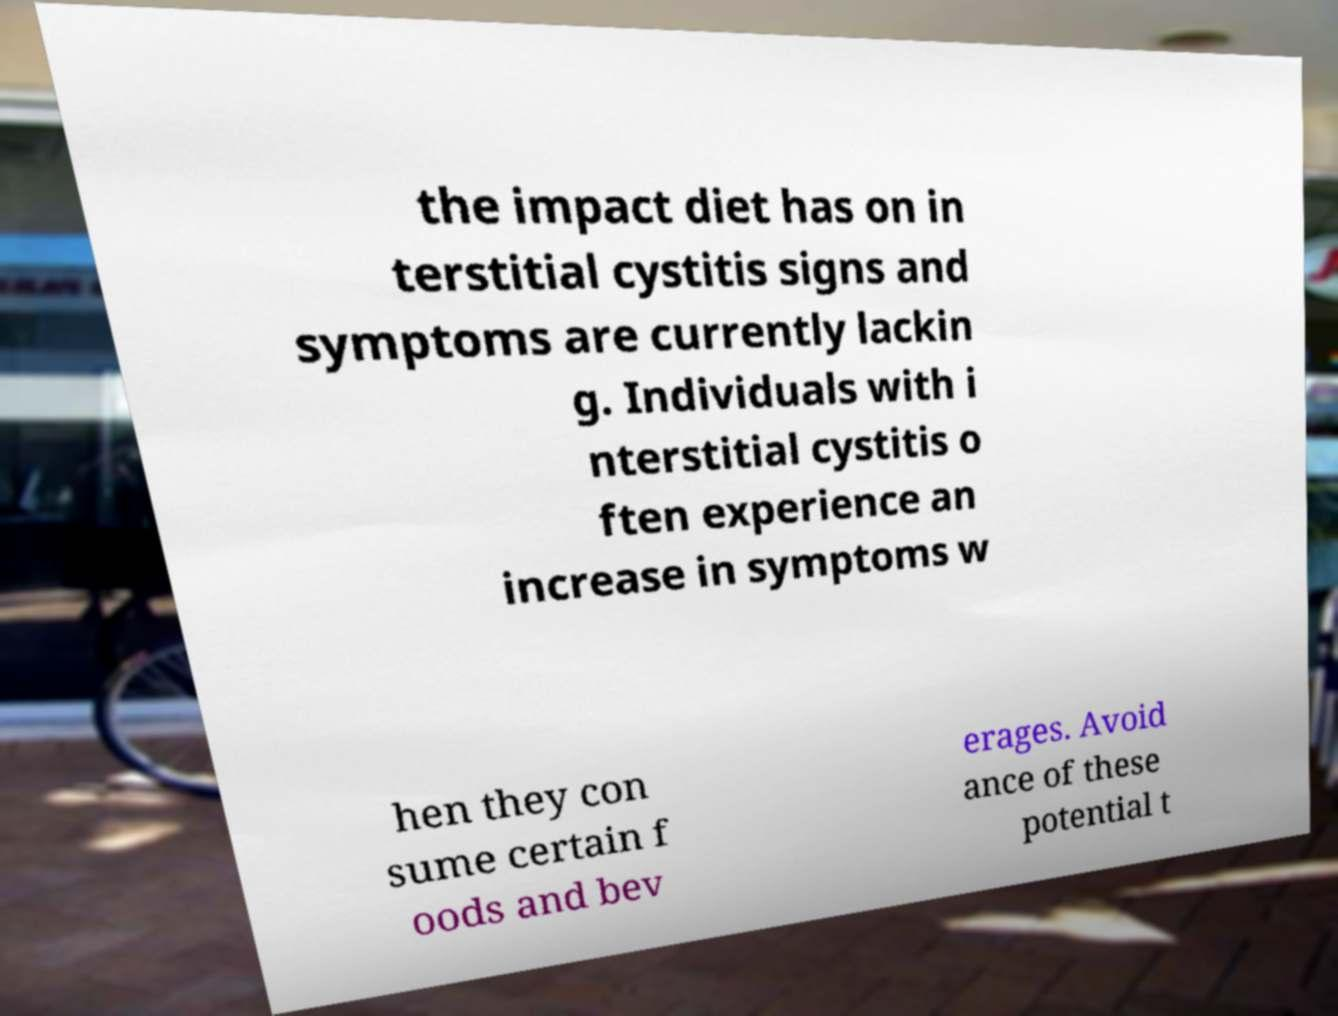For documentation purposes, I need the text within this image transcribed. Could you provide that? the impact diet has on in terstitial cystitis signs and symptoms are currently lackin g. Individuals with i nterstitial cystitis o ften experience an increase in symptoms w hen they con sume certain f oods and bev erages. Avoid ance of these potential t 